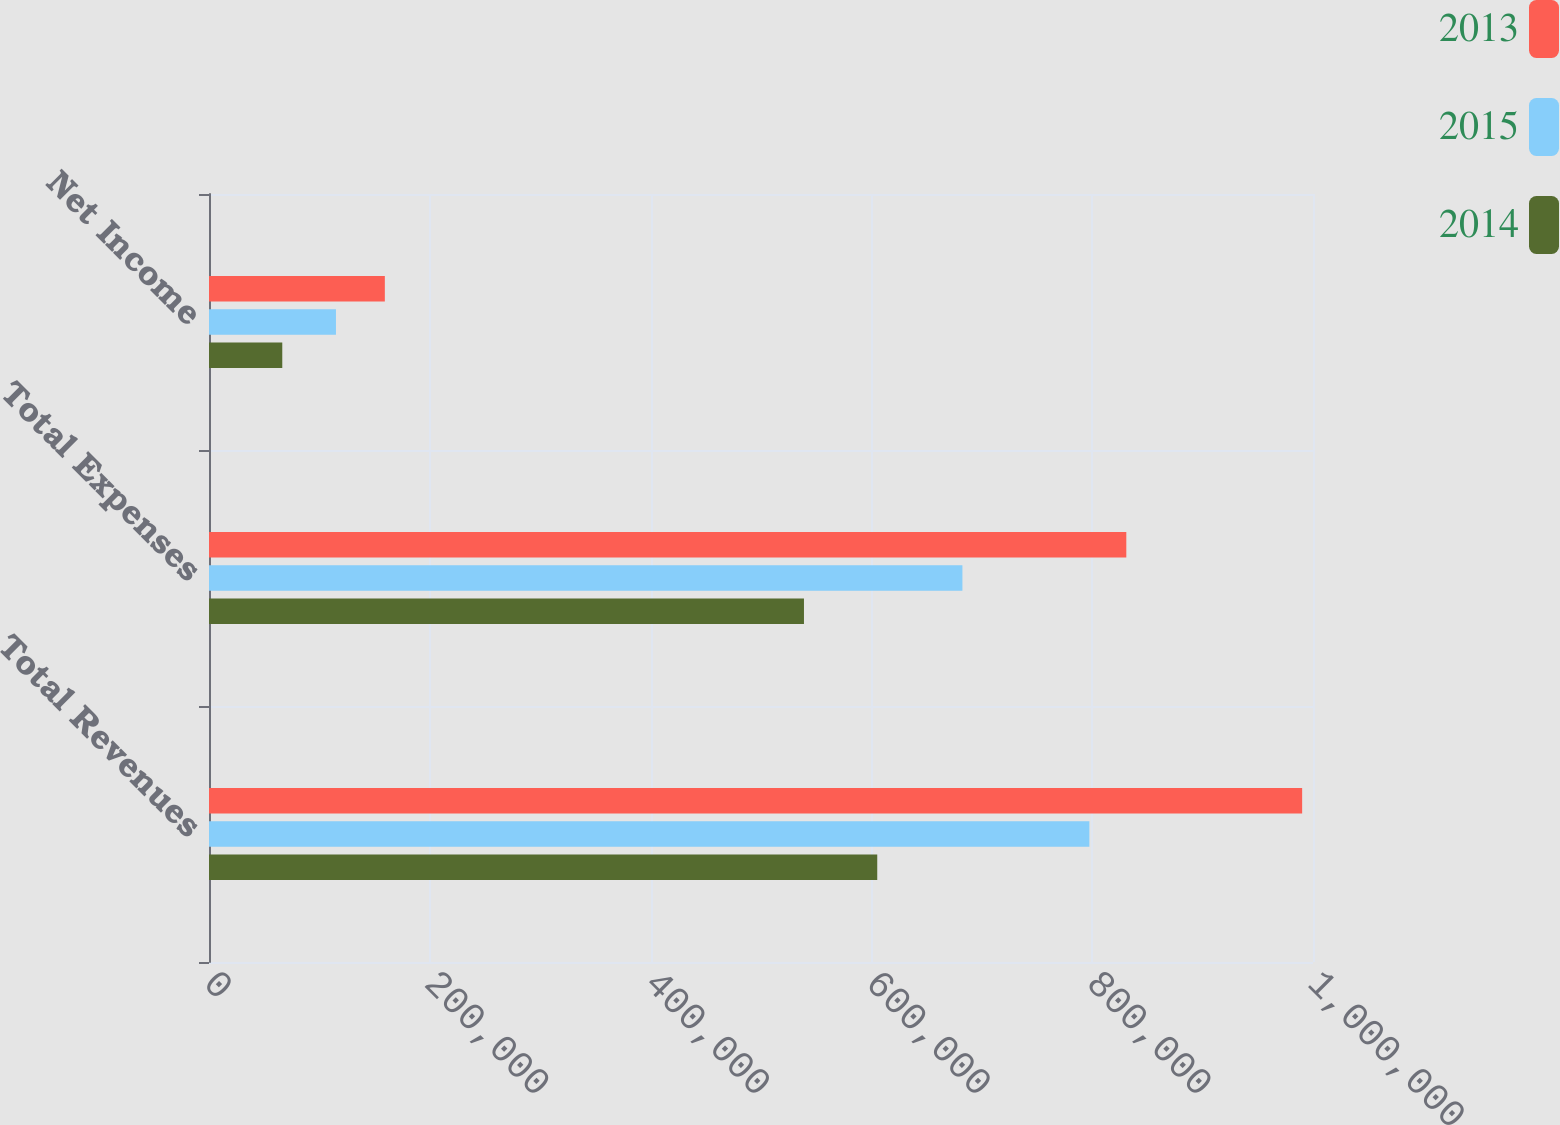Convert chart to OTSL. <chart><loc_0><loc_0><loc_500><loc_500><stacked_bar_chart><ecel><fcel>Total Revenues<fcel>Total Expenses<fcel>Net Income<nl><fcel>2013<fcel>990172<fcel>830898<fcel>159274<nl><fcel>2015<fcel>797441<fcel>682430<fcel>115011<nl><fcel>2014<fcel>605293<fcel>538922<fcel>66371<nl></chart> 